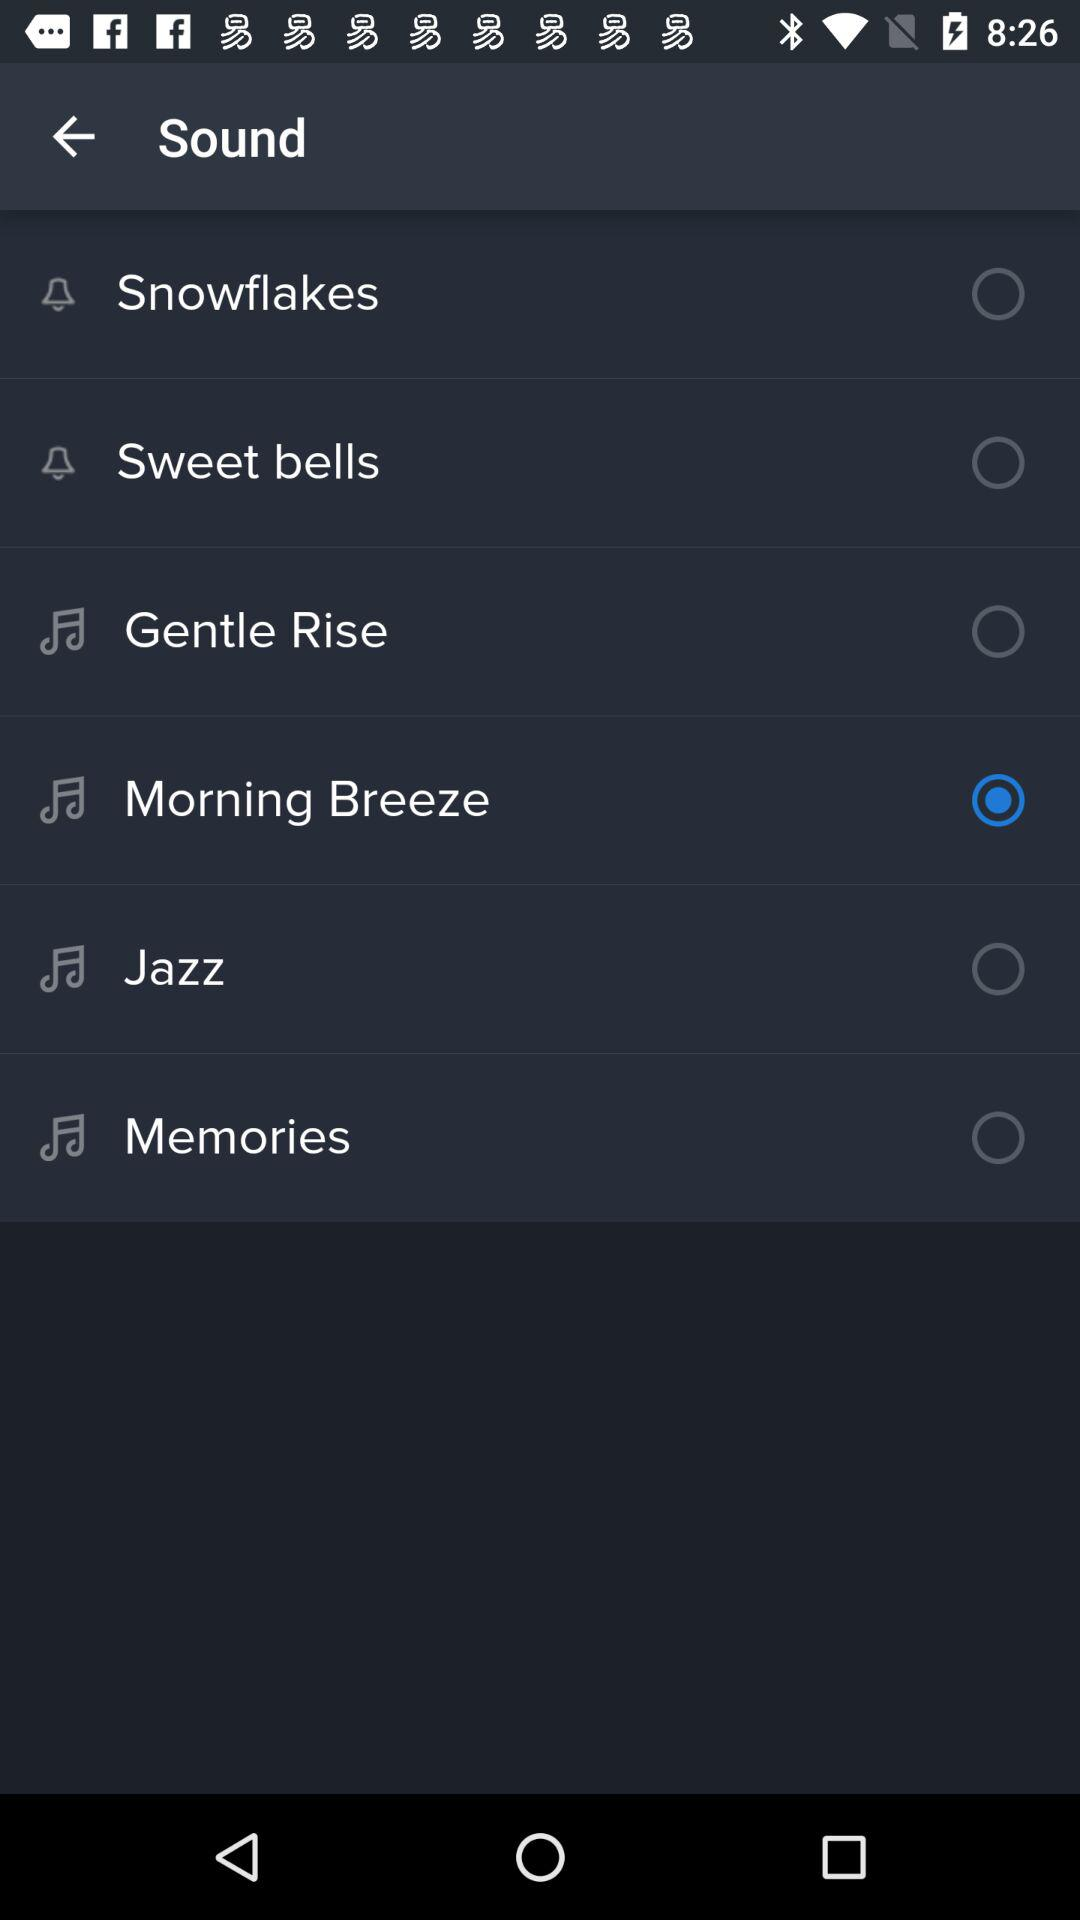Which is the chosen sound tone? The chosen sound tone is "Morning Breeze". 